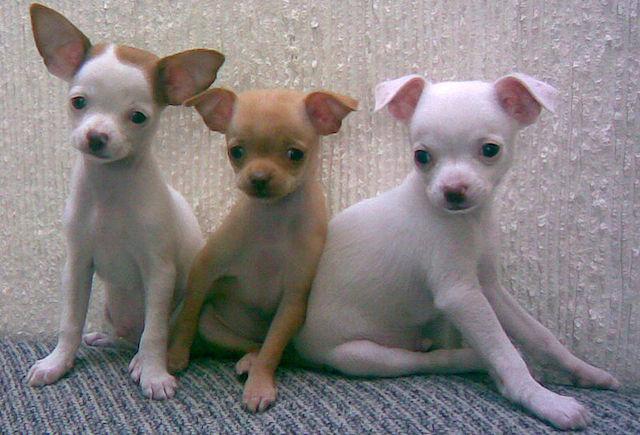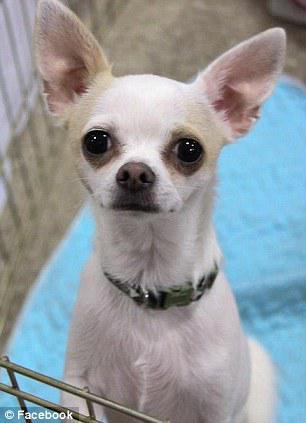The first image is the image on the left, the second image is the image on the right. Analyze the images presented: Is the assertion "Each image includes a white chihuahua, and the one in the right image faces forward with erect ears." valid? Answer yes or no. Yes. The first image is the image on the left, the second image is the image on the right. Assess this claim about the two images: "At least one of the dogs is wearing a collar.". Correct or not? Answer yes or no. Yes. 